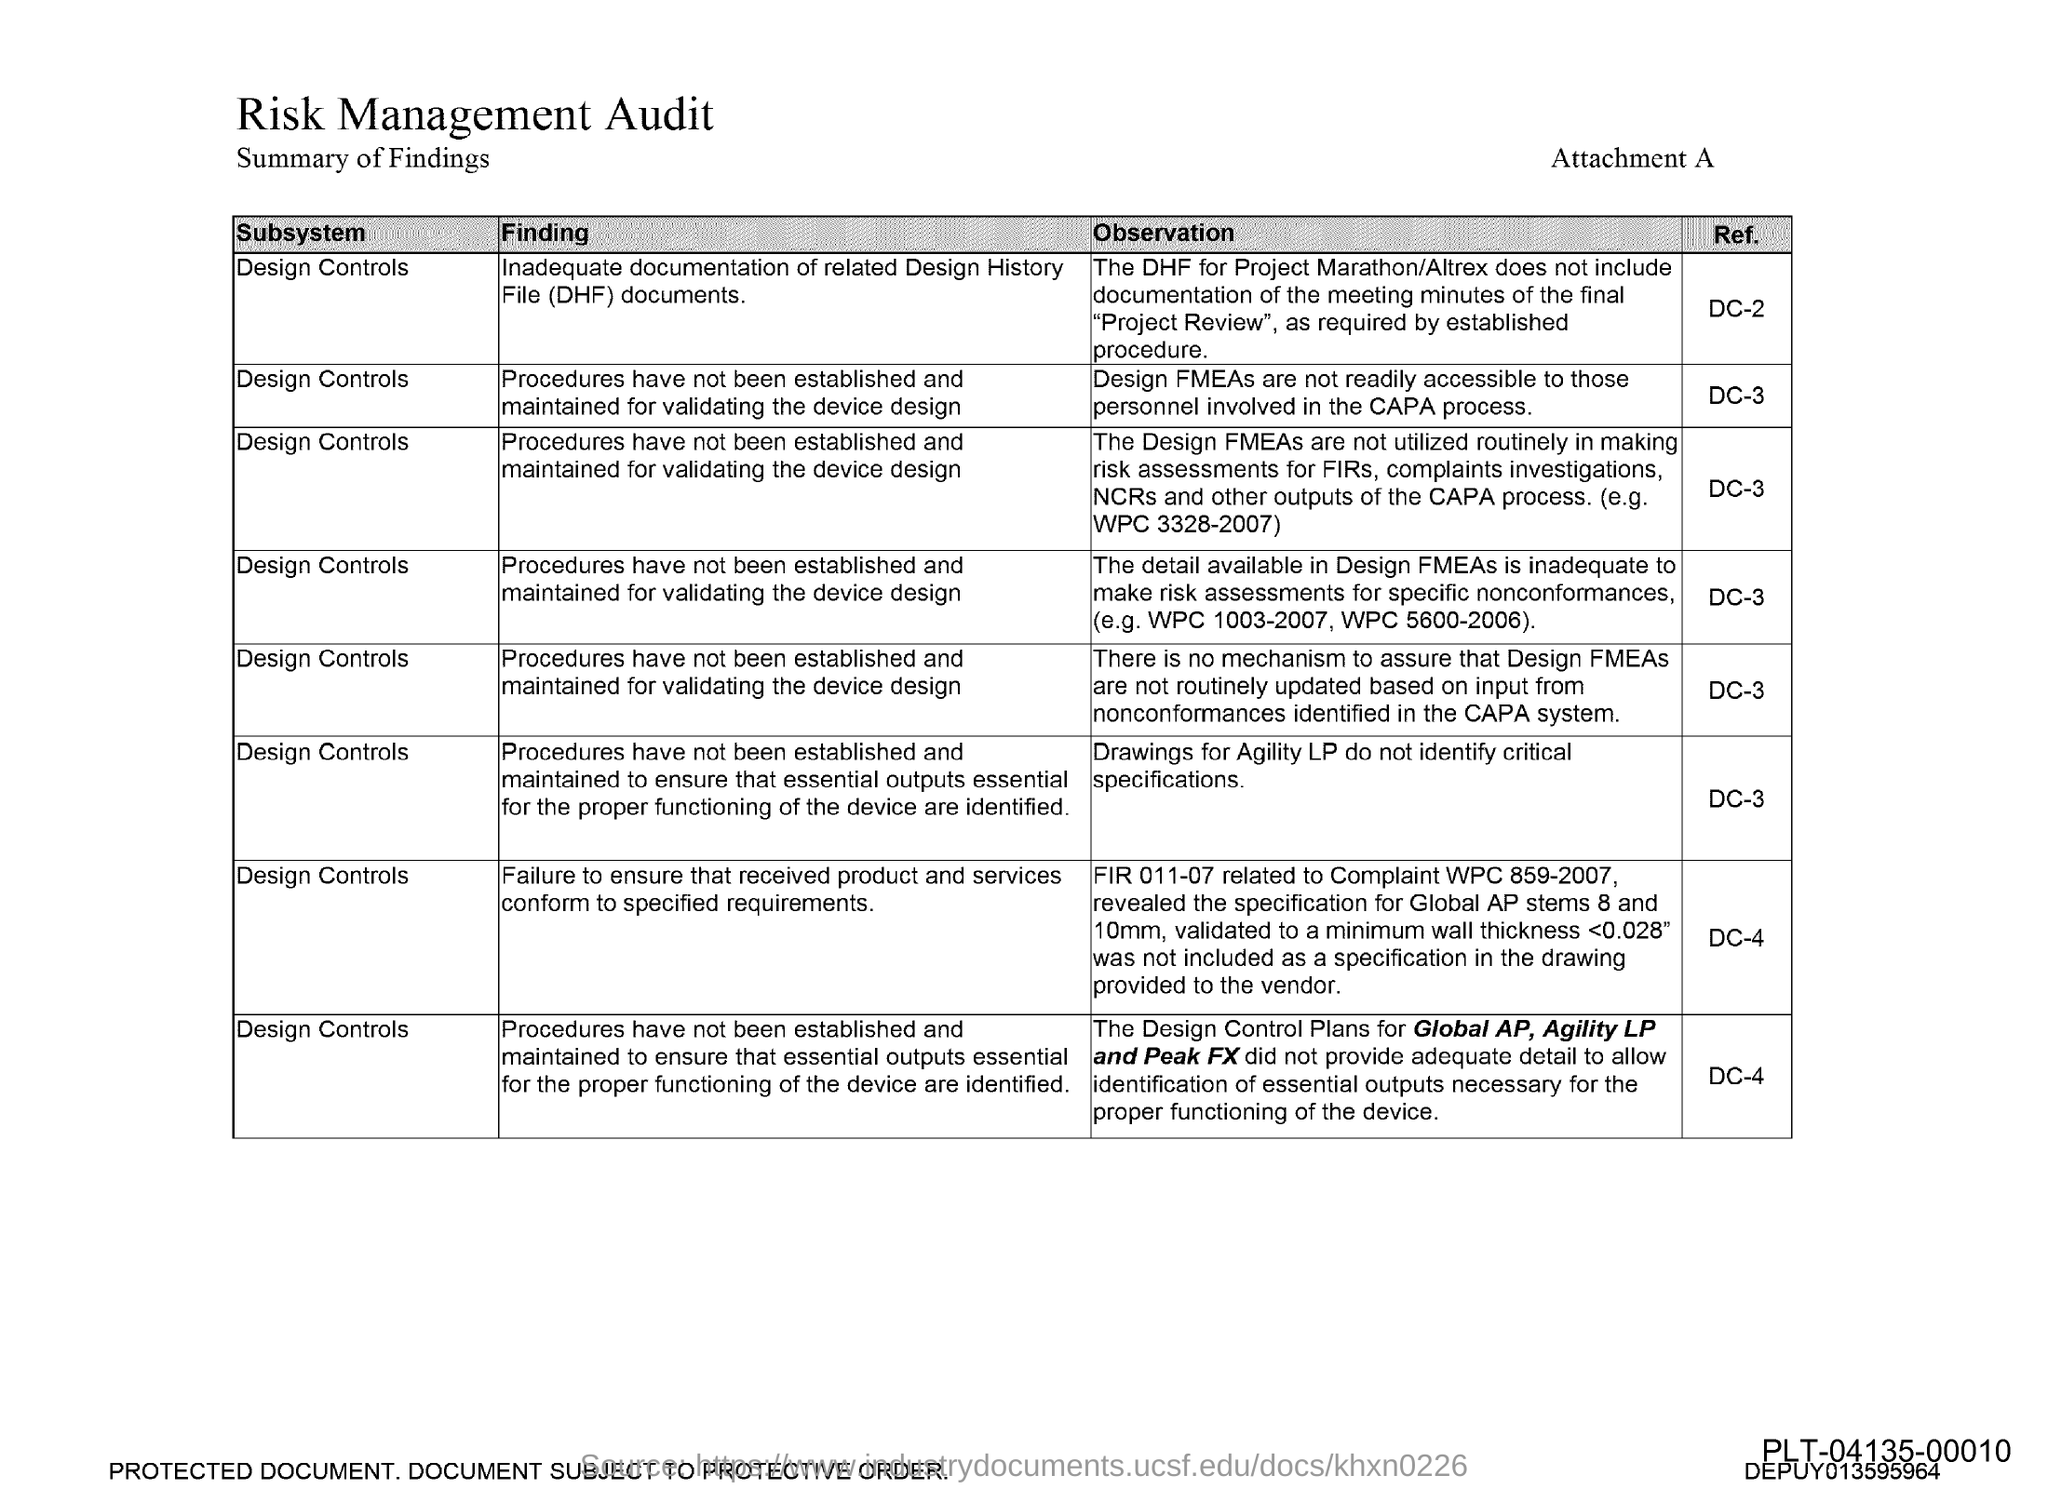Specify some key components in this picture. Drawings for agility do not identify critical specifications. Design FMEAs are not readily accessible to personnel involved in the CAPA process, which limits their ability to identify and address potential design defects and risks. 